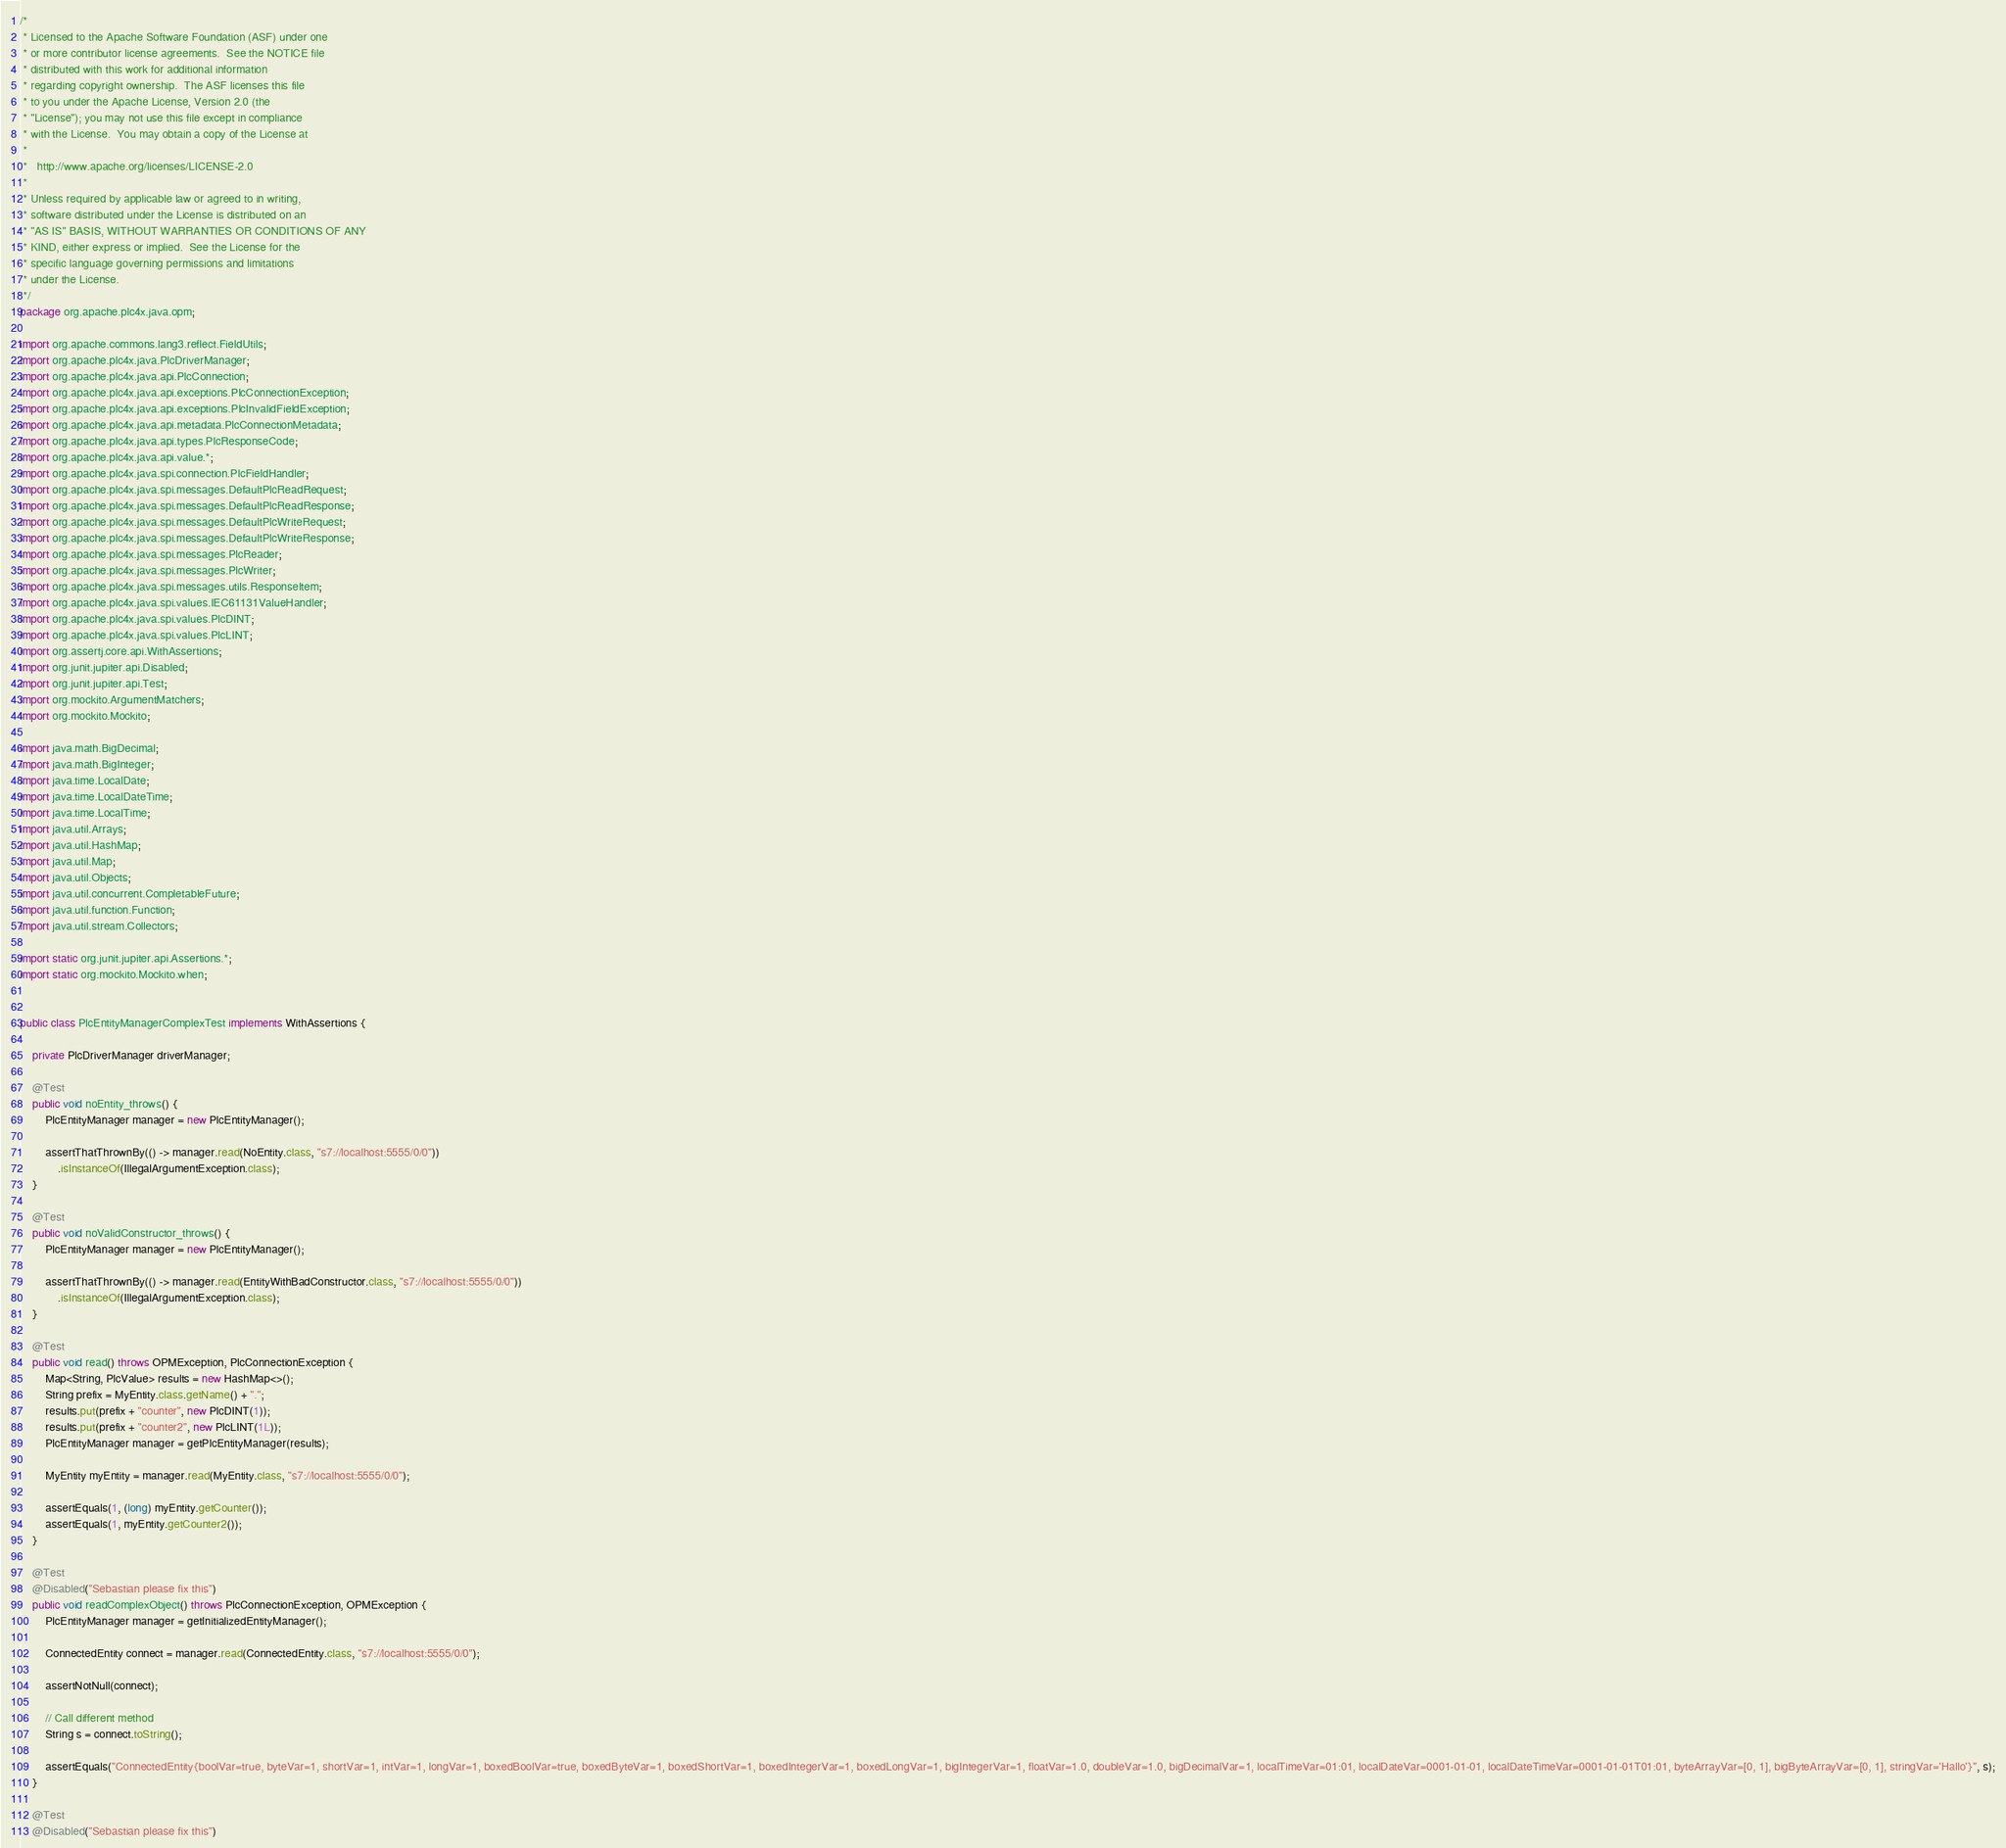<code> <loc_0><loc_0><loc_500><loc_500><_Java_>/*
 * Licensed to the Apache Software Foundation (ASF) under one
 * or more contributor license agreements.  See the NOTICE file
 * distributed with this work for additional information
 * regarding copyright ownership.  The ASF licenses this file
 * to you under the Apache License, Version 2.0 (the
 * "License"); you may not use this file except in compliance
 * with the License.  You may obtain a copy of the License at
 *
 *   http://www.apache.org/licenses/LICENSE-2.0
 *
 * Unless required by applicable law or agreed to in writing,
 * software distributed under the License is distributed on an
 * "AS IS" BASIS, WITHOUT WARRANTIES OR CONDITIONS OF ANY
 * KIND, either express or implied.  See the License for the
 * specific language governing permissions and limitations
 * under the License.
 */
package org.apache.plc4x.java.opm;

import org.apache.commons.lang3.reflect.FieldUtils;
import org.apache.plc4x.java.PlcDriverManager;
import org.apache.plc4x.java.api.PlcConnection;
import org.apache.plc4x.java.api.exceptions.PlcConnectionException;
import org.apache.plc4x.java.api.exceptions.PlcInvalidFieldException;
import org.apache.plc4x.java.api.metadata.PlcConnectionMetadata;
import org.apache.plc4x.java.api.types.PlcResponseCode;
import org.apache.plc4x.java.api.value.*;
import org.apache.plc4x.java.spi.connection.PlcFieldHandler;
import org.apache.plc4x.java.spi.messages.DefaultPlcReadRequest;
import org.apache.plc4x.java.spi.messages.DefaultPlcReadResponse;
import org.apache.plc4x.java.spi.messages.DefaultPlcWriteRequest;
import org.apache.plc4x.java.spi.messages.DefaultPlcWriteResponse;
import org.apache.plc4x.java.spi.messages.PlcReader;
import org.apache.plc4x.java.spi.messages.PlcWriter;
import org.apache.plc4x.java.spi.messages.utils.ResponseItem;
import org.apache.plc4x.java.spi.values.IEC61131ValueHandler;
import org.apache.plc4x.java.spi.values.PlcDINT;
import org.apache.plc4x.java.spi.values.PlcLINT;
import org.assertj.core.api.WithAssertions;
import org.junit.jupiter.api.Disabled;
import org.junit.jupiter.api.Test;
import org.mockito.ArgumentMatchers;
import org.mockito.Mockito;

import java.math.BigDecimal;
import java.math.BigInteger;
import java.time.LocalDate;
import java.time.LocalDateTime;
import java.time.LocalTime;
import java.util.Arrays;
import java.util.HashMap;
import java.util.Map;
import java.util.Objects;
import java.util.concurrent.CompletableFuture;
import java.util.function.Function;
import java.util.stream.Collectors;

import static org.junit.jupiter.api.Assertions.*;
import static org.mockito.Mockito.when;


public class PlcEntityManagerComplexTest implements WithAssertions {

    private PlcDriverManager driverManager;

    @Test
    public void noEntity_throws() {
        PlcEntityManager manager = new PlcEntityManager();

        assertThatThrownBy(() -> manager.read(NoEntity.class, "s7://localhost:5555/0/0"))
            .isInstanceOf(IllegalArgumentException.class);
    }

    @Test
    public void noValidConstructor_throws() {
        PlcEntityManager manager = new PlcEntityManager();

        assertThatThrownBy(() -> manager.read(EntityWithBadConstructor.class, "s7://localhost:5555/0/0"))
            .isInstanceOf(IllegalArgumentException.class);
    }

    @Test
    public void read() throws OPMException, PlcConnectionException {
        Map<String, PlcValue> results = new HashMap<>();
        String prefix = MyEntity.class.getName() + ".";
        results.put(prefix + "counter", new PlcDINT(1));
        results.put(prefix + "counter2", new PlcLINT(1L));
        PlcEntityManager manager = getPlcEntityManager(results);

        MyEntity myEntity = manager.read(MyEntity.class, "s7://localhost:5555/0/0");

        assertEquals(1, (long) myEntity.getCounter());
        assertEquals(1, myEntity.getCounter2());
    }

    @Test
    @Disabled("Sebastian please fix this")
    public void readComplexObject() throws PlcConnectionException, OPMException {
        PlcEntityManager manager = getInitializedEntityManager();

        ConnectedEntity connect = manager.read(ConnectedEntity.class, "s7://localhost:5555/0/0");

        assertNotNull(connect);

        // Call different method
        String s = connect.toString();

        assertEquals("ConnectedEntity{boolVar=true, byteVar=1, shortVar=1, intVar=1, longVar=1, boxedBoolVar=true, boxedByteVar=1, boxedShortVar=1, boxedIntegerVar=1, boxedLongVar=1, bigIntegerVar=1, floatVar=1.0, doubleVar=1.0, bigDecimalVar=1, localTimeVar=01:01, localDateVar=0001-01-01, localDateTimeVar=0001-01-01T01:01, byteArrayVar=[0, 1], bigByteArrayVar=[0, 1], stringVar='Hallo'}", s);
    }

    @Test
    @Disabled("Sebastian please fix this")</code> 